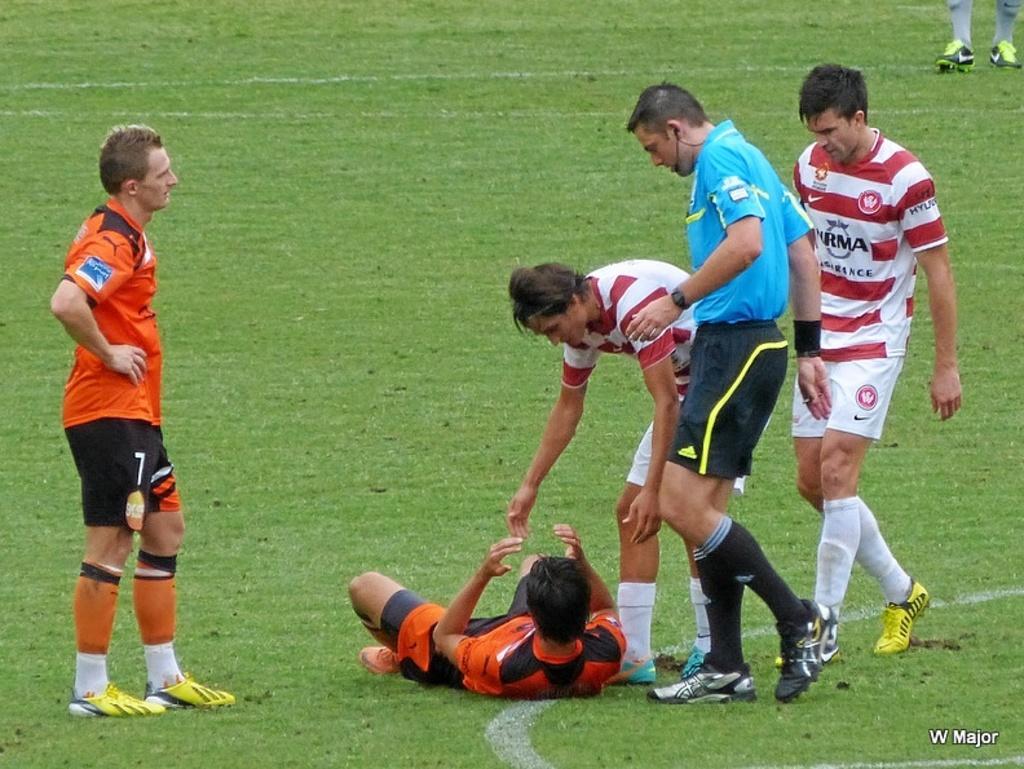Please provide a concise description of this image. In this image we can see one man standing, one man lying on the ground, some text on the bottom right side corner of the image, two persons walking, one man bending to the ground, one person's legs with shoes on the top right side corner of the image and some grass on the green ground. 